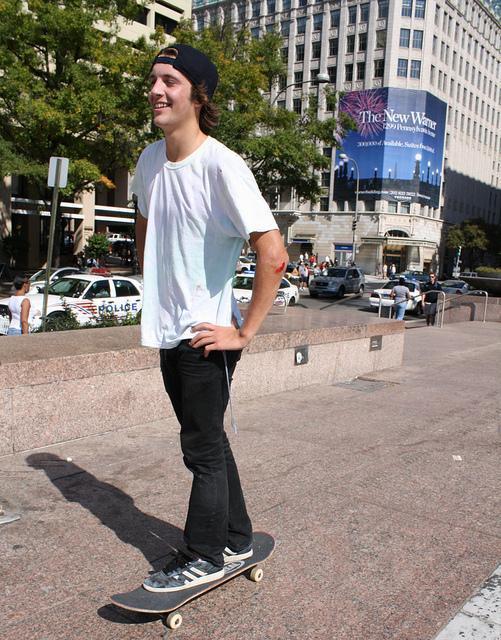How many train cars have some yellow on them?
Give a very brief answer. 0. 